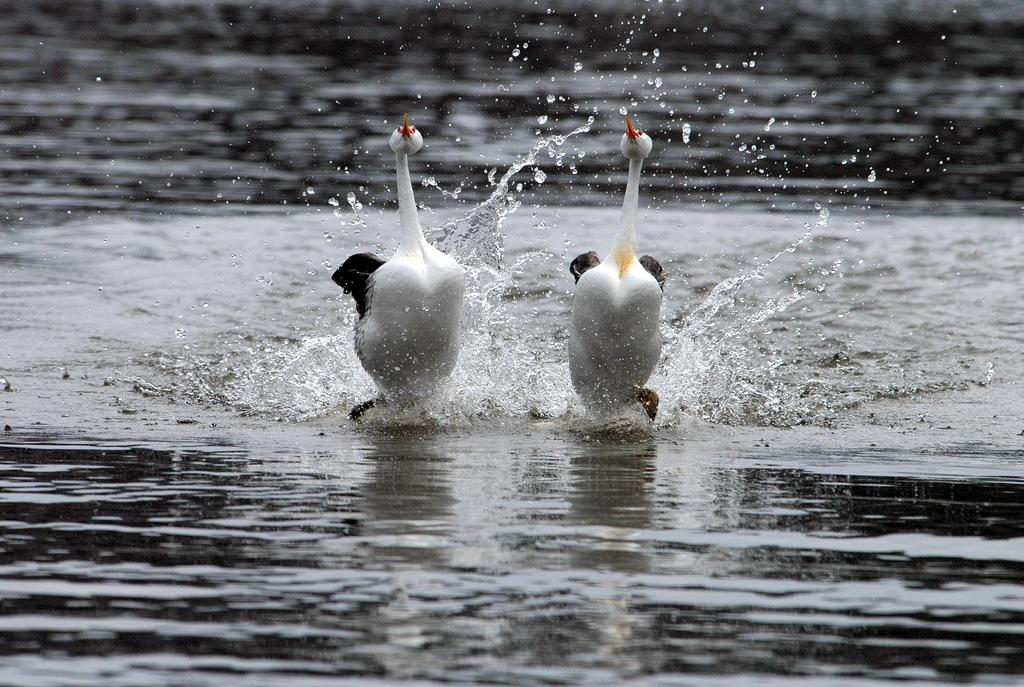What type of animals can be seen in the image? Birds can be seen in the image. What are the birds doing in the image? The birds are running on the water. What type of sponge is being used by the farmer in the image? There is no farmer or sponge present in the image; it features birds running on the water. 